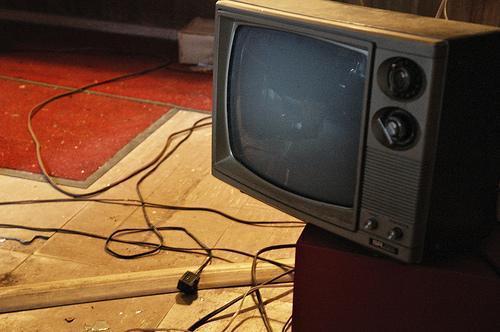How many turning knobs are on the television?
Give a very brief answer. 4. 